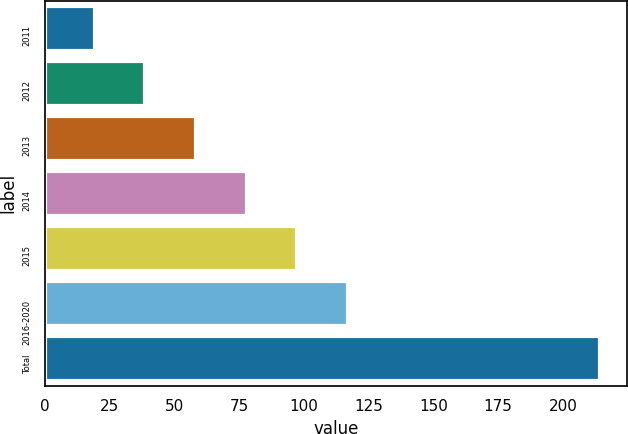Convert chart. <chart><loc_0><loc_0><loc_500><loc_500><bar_chart><fcel>2011<fcel>2012<fcel>2013<fcel>2014<fcel>2015<fcel>2016-2020<fcel>Total<nl><fcel>19<fcel>38.5<fcel>58<fcel>77.5<fcel>97<fcel>116.5<fcel>214<nl></chart> 